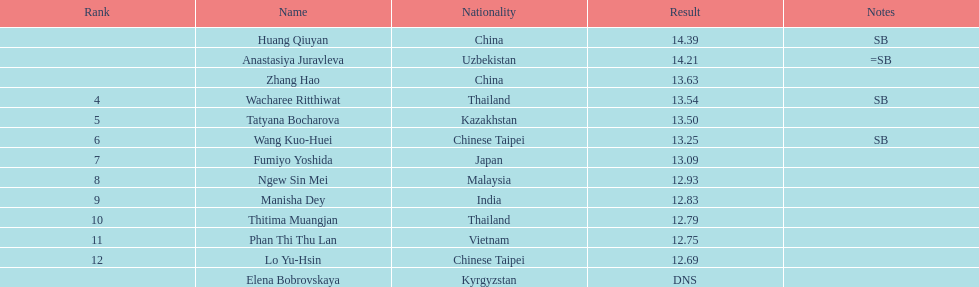Write the full table. {'header': ['Rank', 'Name', 'Nationality', 'Result', 'Notes'], 'rows': [['', 'Huang Qiuyan', 'China', '14.39', 'SB'], ['', 'Anastasiya Juravleva', 'Uzbekistan', '14.21', '=SB'], ['', 'Zhang Hao', 'China', '13.63', ''], ['4', 'Wacharee Ritthiwat', 'Thailand', '13.54', 'SB'], ['5', 'Tatyana Bocharova', 'Kazakhstan', '13.50', ''], ['6', 'Wang Kuo-Huei', 'Chinese Taipei', '13.25', 'SB'], ['7', 'Fumiyo Yoshida', 'Japan', '13.09', ''], ['8', 'Ngew Sin Mei', 'Malaysia', '12.93', ''], ['9', 'Manisha Dey', 'India', '12.83', ''], ['10', 'Thitima Muangjan', 'Thailand', '12.79', ''], ['11', 'Phan Thi Thu Lan', 'Vietnam', '12.75', ''], ['12', 'Lo Yu-Hsin', 'Chinese Taipei', '12.69', ''], ['', 'Elena Bobrovskaya', 'Kyrgyzstan', 'DNS', '']]} How many participants were from thailand? 2. 